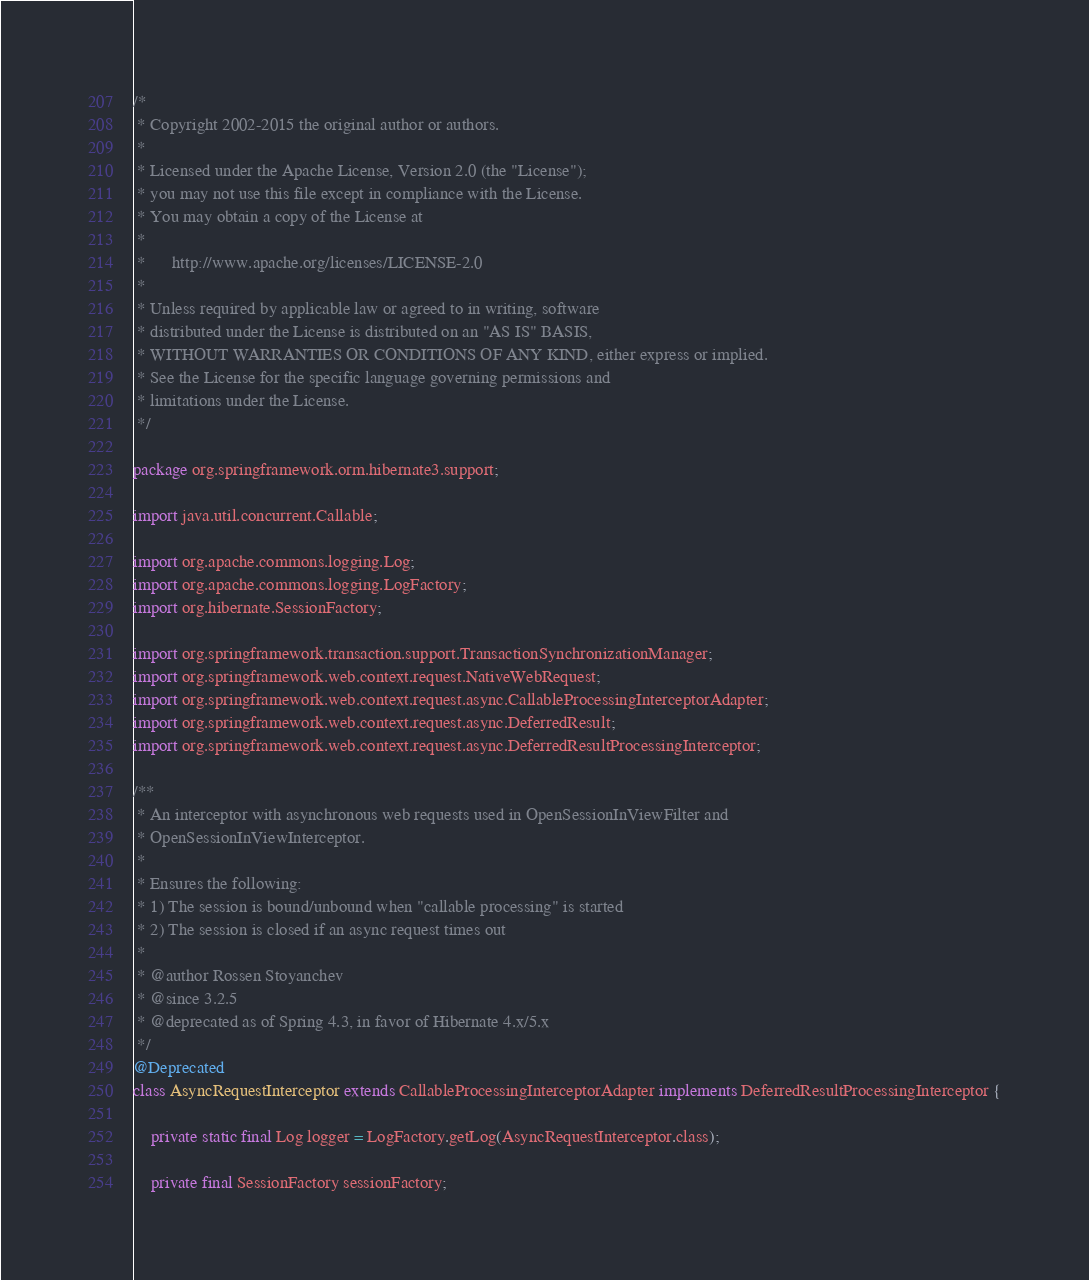<code> <loc_0><loc_0><loc_500><loc_500><_Java_>/*
 * Copyright 2002-2015 the original author or authors.
 *
 * Licensed under the Apache License, Version 2.0 (the "License");
 * you may not use this file except in compliance with the License.
 * You may obtain a copy of the License at
 *
 *      http://www.apache.org/licenses/LICENSE-2.0
 *
 * Unless required by applicable law or agreed to in writing, software
 * distributed under the License is distributed on an "AS IS" BASIS,
 * WITHOUT WARRANTIES OR CONDITIONS OF ANY KIND, either express or implied.
 * See the License for the specific language governing permissions and
 * limitations under the License.
 */

package org.springframework.orm.hibernate3.support;

import java.util.concurrent.Callable;

import org.apache.commons.logging.Log;
import org.apache.commons.logging.LogFactory;
import org.hibernate.SessionFactory;

import org.springframework.transaction.support.TransactionSynchronizationManager;
import org.springframework.web.context.request.NativeWebRequest;
import org.springframework.web.context.request.async.CallableProcessingInterceptorAdapter;
import org.springframework.web.context.request.async.DeferredResult;
import org.springframework.web.context.request.async.DeferredResultProcessingInterceptor;

/**
 * An interceptor with asynchronous web requests used in OpenSessionInViewFilter and
 * OpenSessionInViewInterceptor.
 *
 * Ensures the following:
 * 1) The session is bound/unbound when "callable processing" is started
 * 2) The session is closed if an async request times out
 *
 * @author Rossen Stoyanchev
 * @since 3.2.5
 * @deprecated as of Spring 4.3, in favor of Hibernate 4.x/5.x
 */
@Deprecated
class AsyncRequestInterceptor extends CallableProcessingInterceptorAdapter implements DeferredResultProcessingInterceptor {

	private static final Log logger = LogFactory.getLog(AsyncRequestInterceptor.class);

	private final SessionFactory sessionFactory;
</code> 